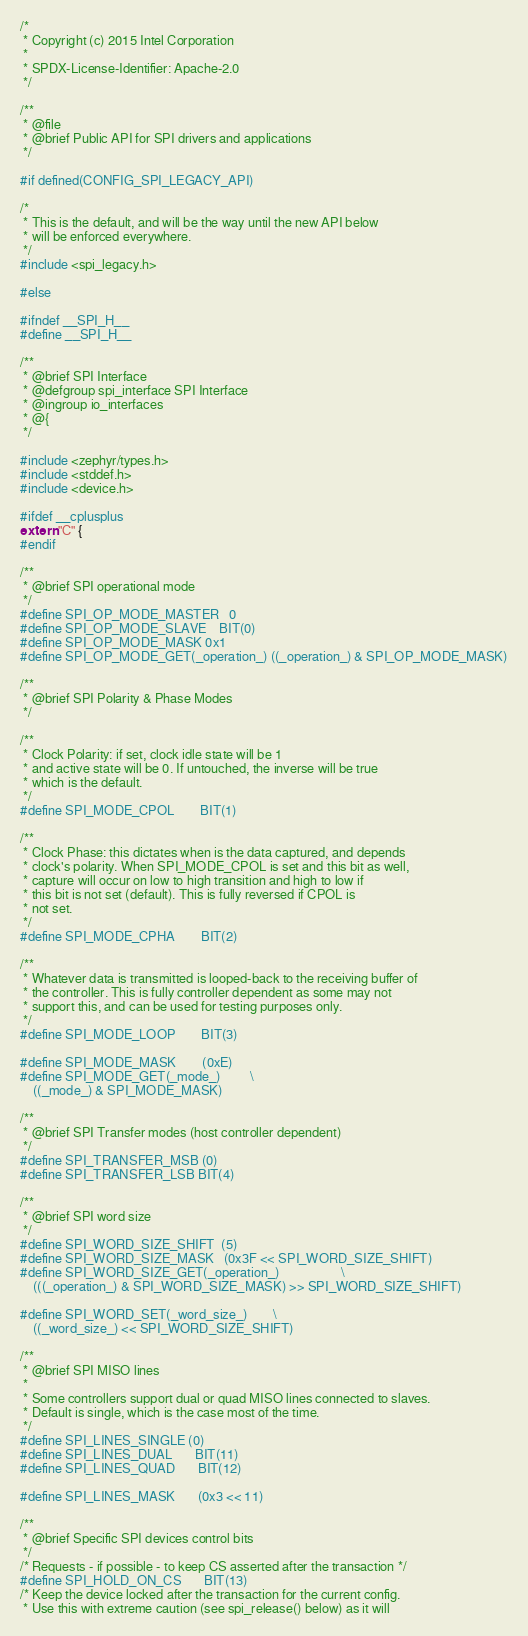<code> <loc_0><loc_0><loc_500><loc_500><_C_>/*
 * Copyright (c) 2015 Intel Corporation
 *
 * SPDX-License-Identifier: Apache-2.0
 */

/**
 * @file
 * @brief Public API for SPI drivers and applications
 */

#if defined(CONFIG_SPI_LEGACY_API)

/*
 * This is the default, and will be the way until the new API below
 * will be enforced everywhere.
 */
#include <spi_legacy.h>

#else

#ifndef __SPI_H__
#define __SPI_H__

/**
 * @brief SPI Interface
 * @defgroup spi_interface SPI Interface
 * @ingroup io_interfaces
 * @{
 */

#include <zephyr/types.h>
#include <stddef.h>
#include <device.h>

#ifdef __cplusplus
extern "C" {
#endif

/**
 * @brief SPI operational mode
 */
#define SPI_OP_MODE_MASTER	0
#define SPI_OP_MODE_SLAVE	BIT(0)
#define SPI_OP_MODE_MASK	0x1
#define SPI_OP_MODE_GET(_operation_) ((_operation_) & SPI_OP_MODE_MASK)

/**
 * @brief SPI Polarity & Phase Modes
 */

/**
 * Clock Polarity: if set, clock idle state will be 1
 * and active state will be 0. If untouched, the inverse will be true
 * which is the default.
 */
#define SPI_MODE_CPOL		BIT(1)

/**
 * Clock Phase: this dictates when is the data captured, and depends
 * clock's polarity. When SPI_MODE_CPOL is set and this bit as well,
 * capture will occur on low to high transition and high to low if
 * this bit is not set (default). This is fully reversed if CPOL is
 * not set.
 */
#define SPI_MODE_CPHA		BIT(2)

/**
 * Whatever data is transmitted is looped-back to the receiving buffer of
 * the controller. This is fully controller dependent as some may not
 * support this, and can be used for testing purposes only.
 */
#define SPI_MODE_LOOP		BIT(3)

#define SPI_MODE_MASK		(0xE)
#define SPI_MODE_GET(_mode_)			\
	((_mode_) & SPI_MODE_MASK)

/**
 * @brief SPI Transfer modes (host controller dependent)
 */
#define SPI_TRANSFER_MSB	(0)
#define SPI_TRANSFER_LSB	BIT(4)

/**
 * @brief SPI word size
 */
#define SPI_WORD_SIZE_SHIFT	(5)
#define SPI_WORD_SIZE_MASK	(0x3F << SPI_WORD_SIZE_SHIFT)
#define SPI_WORD_SIZE_GET(_operation_)					\
	(((_operation_) & SPI_WORD_SIZE_MASK) >> SPI_WORD_SIZE_SHIFT)

#define SPI_WORD_SET(_word_size_)		\
	((_word_size_) << SPI_WORD_SIZE_SHIFT)

/**
 * @brief SPI MISO lines
 *
 * Some controllers support dual or quad MISO lines connected to slaves.
 * Default is single, which is the case most of the time.
 */
#define SPI_LINES_SINGLE	(0)
#define SPI_LINES_DUAL		BIT(11)
#define SPI_LINES_QUAD		BIT(12)

#define SPI_LINES_MASK		(0x3 << 11)

/**
 * @brief Specific SPI devices control bits
 */
/* Requests - if possible - to keep CS asserted after the transaction */
#define SPI_HOLD_ON_CS		BIT(13)
/* Keep the device locked after the transaction for the current config.
 * Use this with extreme caution (see spi_release() below) as it will</code> 